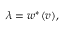<formula> <loc_0><loc_0><loc_500><loc_500>\lambda = w ^ { * } ( v ) ,</formula> 